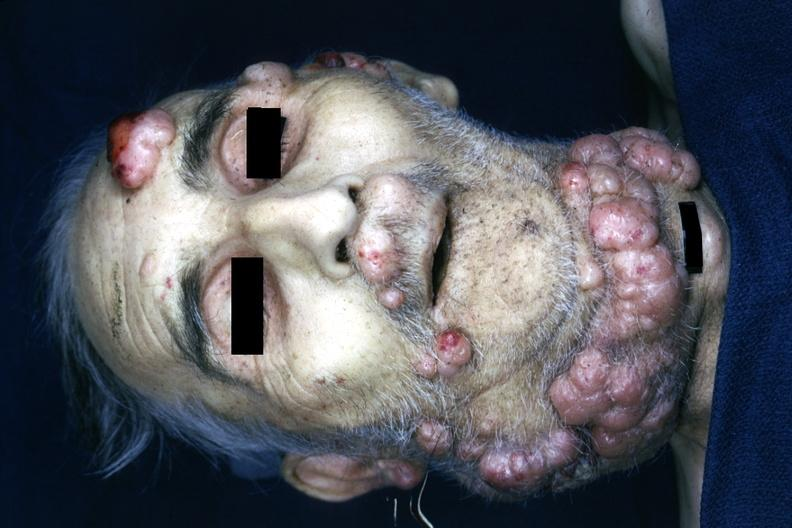s mesothelioma present?
Answer the question using a single word or phrase. No 